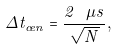Convert formula to latex. <formula><loc_0><loc_0><loc_500><loc_500>\Delta t _ { c e n } = \frac { 2 \ \mu s } { \sqrt { N } } ,</formula> 